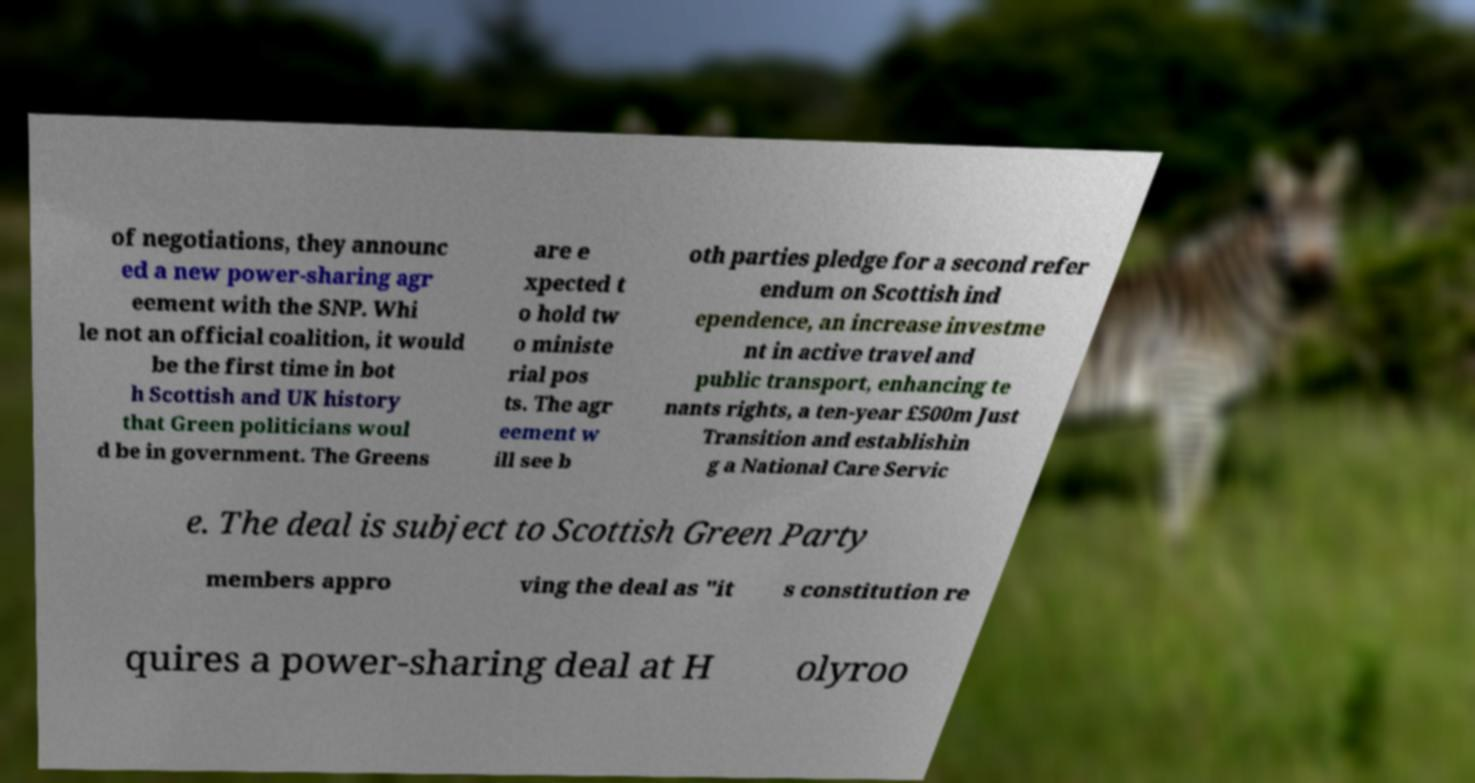There's text embedded in this image that I need extracted. Can you transcribe it verbatim? of negotiations, they announc ed a new power-sharing agr eement with the SNP. Whi le not an official coalition, it would be the first time in bot h Scottish and UK history that Green politicians woul d be in government. The Greens are e xpected t o hold tw o ministe rial pos ts. The agr eement w ill see b oth parties pledge for a second refer endum on Scottish ind ependence, an increase investme nt in active travel and public transport, enhancing te nants rights, a ten-year £500m Just Transition and establishin g a National Care Servic e. The deal is subject to Scottish Green Party members appro ving the deal as "it s constitution re quires a power-sharing deal at H olyroo 